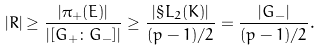<formula> <loc_0><loc_0><loc_500><loc_500>| R | \geq \frac { | \pi _ { + } ( E ) | } { | [ G _ { + } \colon G _ { - } ] | } \geq \frac { | \S L _ { 2 } ( K ) | } { ( p - 1 ) / 2 } = \frac { | G _ { - } | } { ( p - 1 ) / 2 } .</formula> 